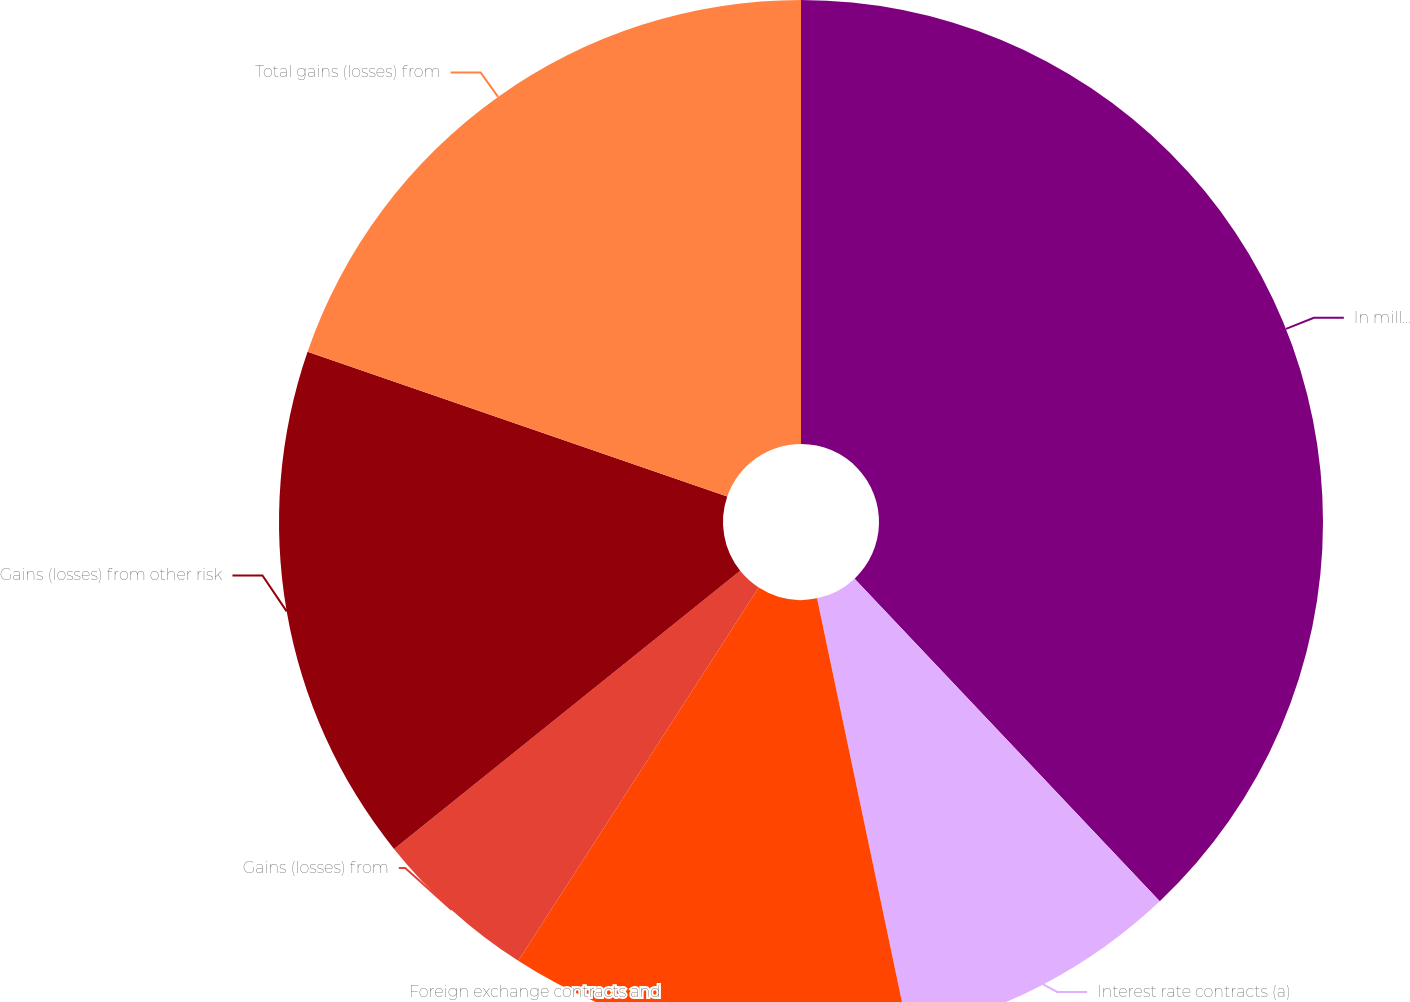<chart> <loc_0><loc_0><loc_500><loc_500><pie_chart><fcel>In millions<fcel>Interest rate contracts (a)<fcel>Foreign exchange contracts and<fcel>Gains (losses) from<fcel>Gains (losses) from other risk<fcel>Total gains (losses) from<nl><fcel>37.94%<fcel>8.76%<fcel>12.41%<fcel>5.12%<fcel>16.06%<fcel>19.71%<nl></chart> 